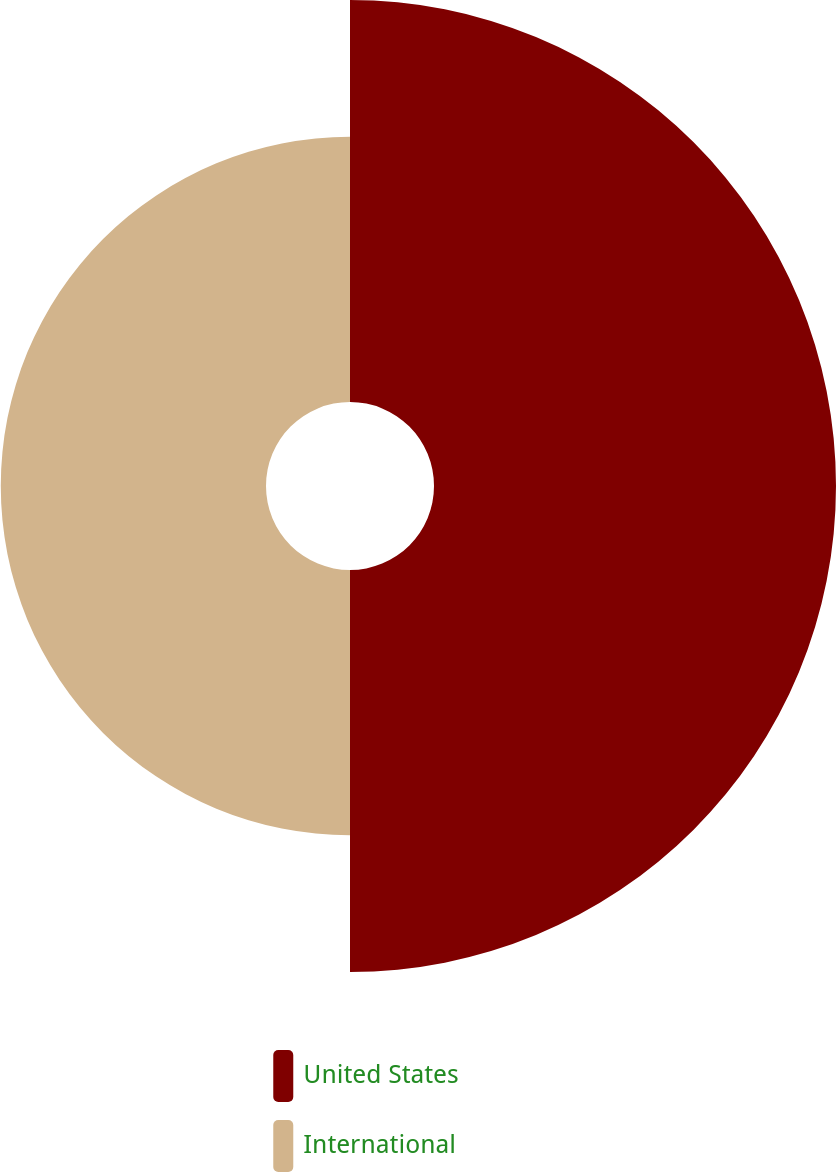Convert chart. <chart><loc_0><loc_0><loc_500><loc_500><pie_chart><fcel>United States<fcel>International<nl><fcel>60.25%<fcel>39.75%<nl></chart> 